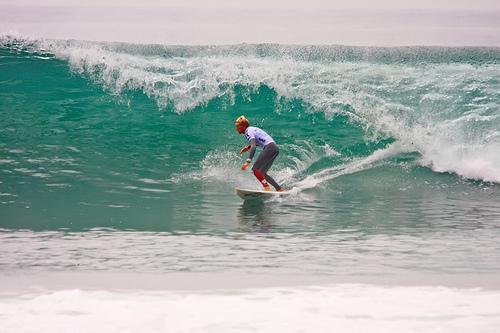How many guys are there?
Give a very brief answer. 1. 